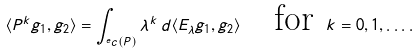Convert formula to latex. <formula><loc_0><loc_0><loc_500><loc_500>\langle P ^ { k } g _ { 1 } , g _ { 2 } \rangle = \int _ { ^ { e } c ( P ) } \lambda ^ { k } \, d \langle E _ { \lambda } g _ { 1 } , g _ { 2 } \rangle \quad \text {for} \ k = 0 , 1 , \dots .</formula> 